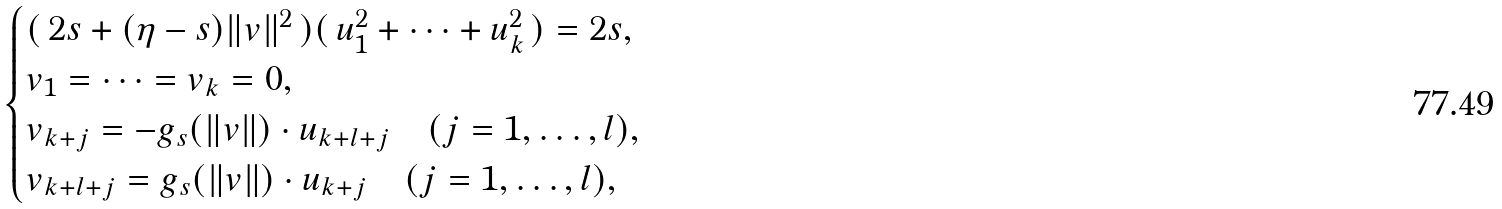<formula> <loc_0><loc_0><loc_500><loc_500>\begin{cases} ( \, 2 s + ( \eta - s ) \| v \| ^ { 2 } \, ) ( \, u _ { 1 } ^ { 2 } + \cdots + u _ { k } ^ { 2 } \, ) = 2 s , & \\ v _ { 1 } = \dots = v _ { k } = 0 , & \\ v _ { k + j } = - g _ { s } ( \| v \| ) \cdot u _ { k + l + j } \quad ( j = 1 , \dots , l ) , & \\ v _ { k + l + j } = g _ { s } ( \| v \| ) \cdot u _ { k + j } \quad ( j = 1 , \dots , l ) , & \end{cases}</formula> 